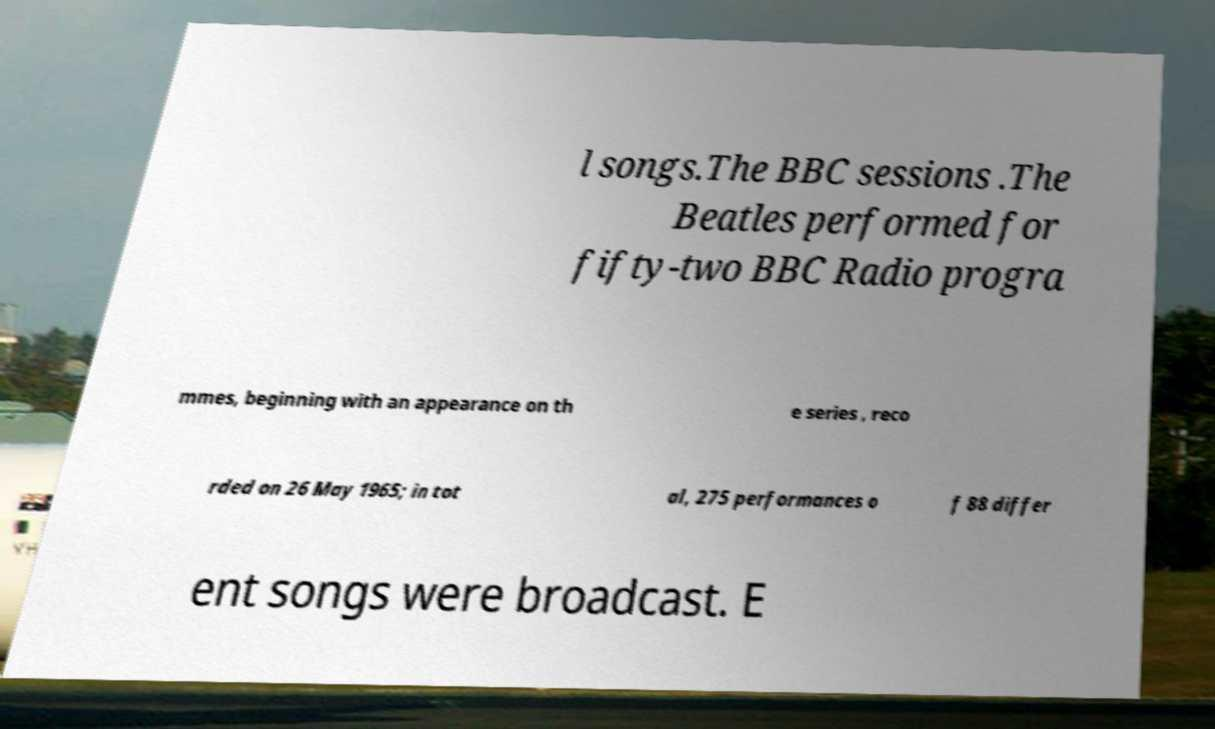Could you assist in decoding the text presented in this image and type it out clearly? l songs.The BBC sessions .The Beatles performed for fifty-two BBC Radio progra mmes, beginning with an appearance on th e series , reco rded on 26 May 1965; in tot al, 275 performances o f 88 differ ent songs were broadcast. E 